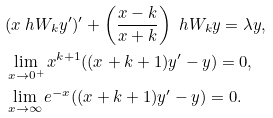<formula> <loc_0><loc_0><loc_500><loc_500>& ( x \ h W _ { k } y ^ { \prime } ) ^ { \prime } + \left ( \frac { x - k } { x + k } \right ) \ h W _ { k } y = \lambda y , \\ & \lim _ { x \to 0 ^ { + } } x ^ { k + 1 } ( ( x + k + 1 ) y ^ { \prime } - y ) = 0 , \\ & \lim _ { x \to \infty } e ^ { - x } ( ( x + k + 1 ) y ^ { \prime } - y ) = 0 .</formula> 